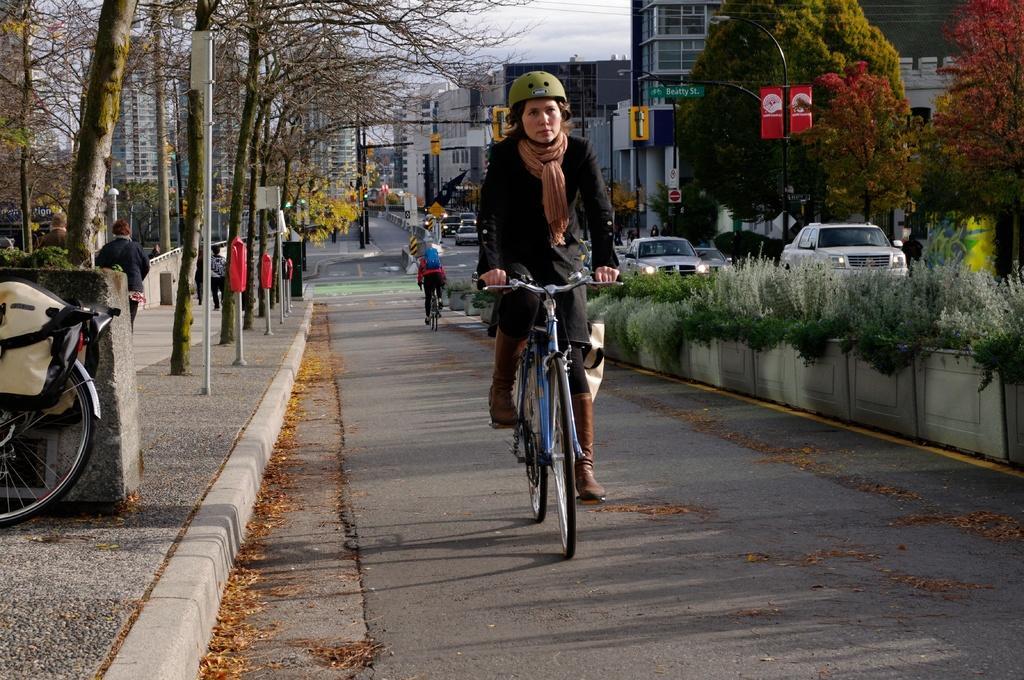Describe this image in one or two sentences. In this image I can see a woman is cycling her cycle. I can also see she is wearing a helmet. In the background I can see few more people, vehicles, trees, street lights and number of buildings. 